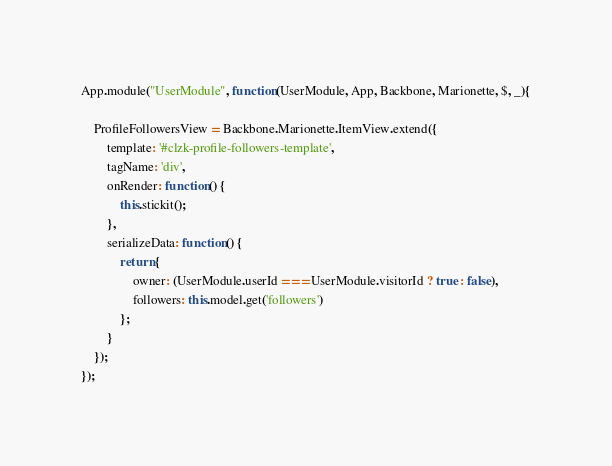Convert code to text. <code><loc_0><loc_0><loc_500><loc_500><_JavaScript_>App.module("UserModule", function(UserModule, App, Backbone, Marionette, $, _){

    ProfileFollowersView = Backbone.Marionette.ItemView.extend({
        template: '#clzk-profile-followers-template',
        tagName: 'div',
        onRender: function() {
            this.stickit();
        },
        serializeData: function() {
            return {
            	owner: (UserModule.userId === UserModule.visitorId ? true : false),
                followers: this.model.get('followers')
            };
        }
    });
});</code> 